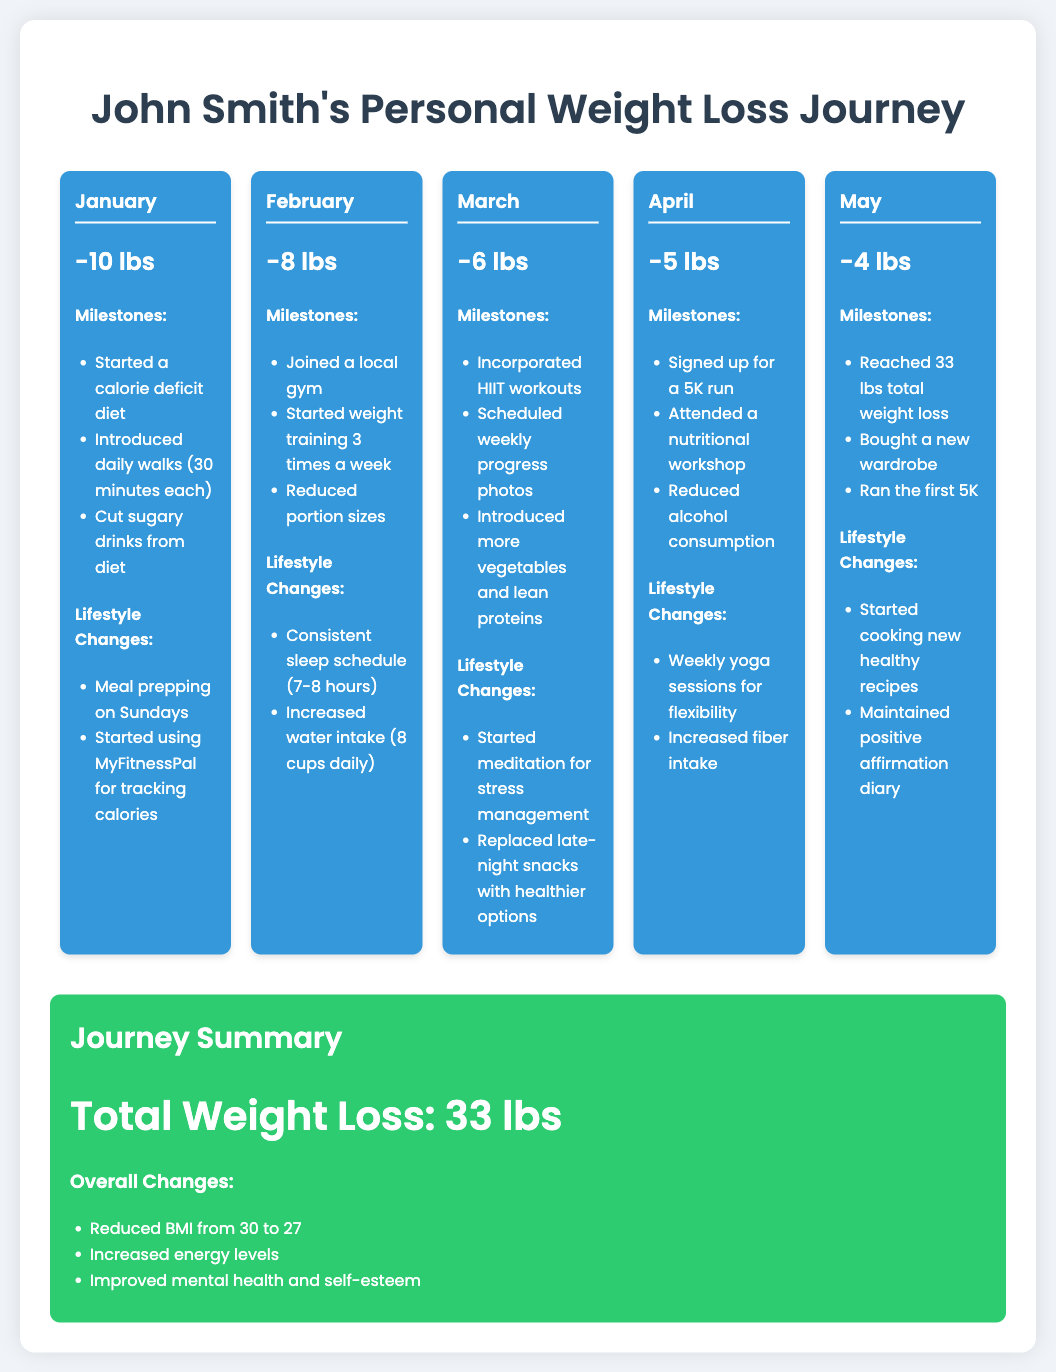how much weight did John lose in January? January's entry states a weight loss of 10 lbs.
Answer: 10 lbs what is the total weight loss by May? The journey summary states the total weight loss is 33 lbs.
Answer: 33 lbs how many pounds did John lose in February? The February entry indicates a weight loss of 8 lbs.
Answer: 8 lbs what was one of the milestones in April? One of the milestones listed for April was signing up for a 5K run.
Answer: signed up for a 5K run what lifestyle change was introduced in March? One of the lifestyle changes in March was starting meditation for stress management.
Answer: started meditation for stress management how many times a week did John start weight training in February? February's milestones show he started weight training 3 times a week.
Answer: 3 times how many months did the journey last? The timeline shows entries for five months from January to May.
Answer: 5 months what was a key lifestyle change noted for the entire journey? Increased energy levels are mentioned as an overall change in the journey summary.
Answer: Increased energy levels what did John do every Sunday? The January entry mentions meal prepping on Sundays.
Answer: meal prepping on Sundays 